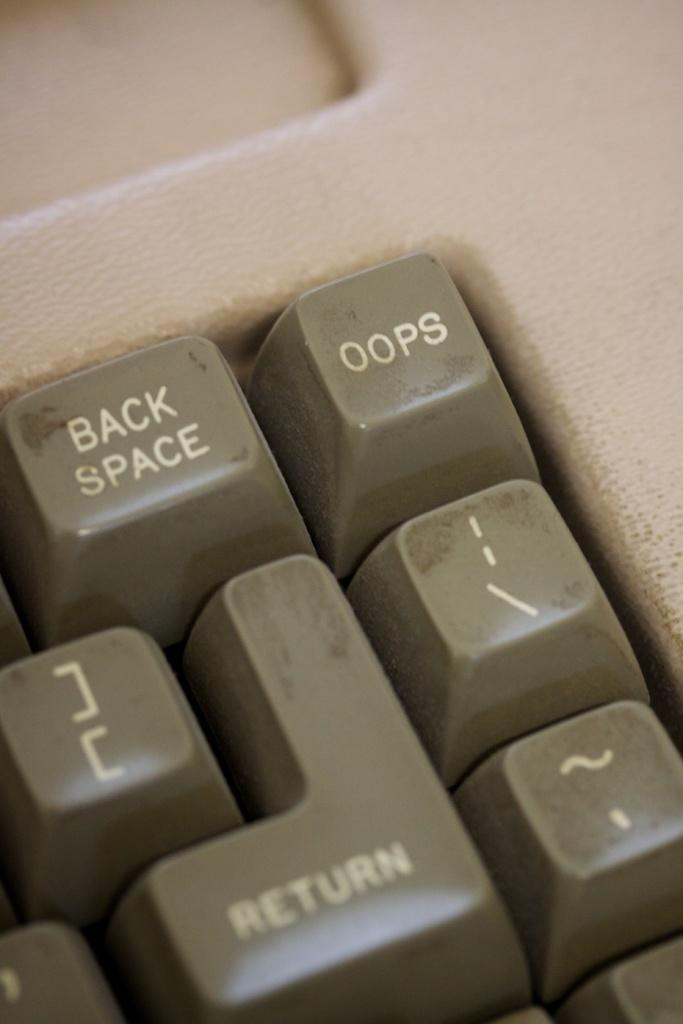Provide a one-sentence caption for the provided image. The top right corner of an old keyboard with a backspace and oops button. 